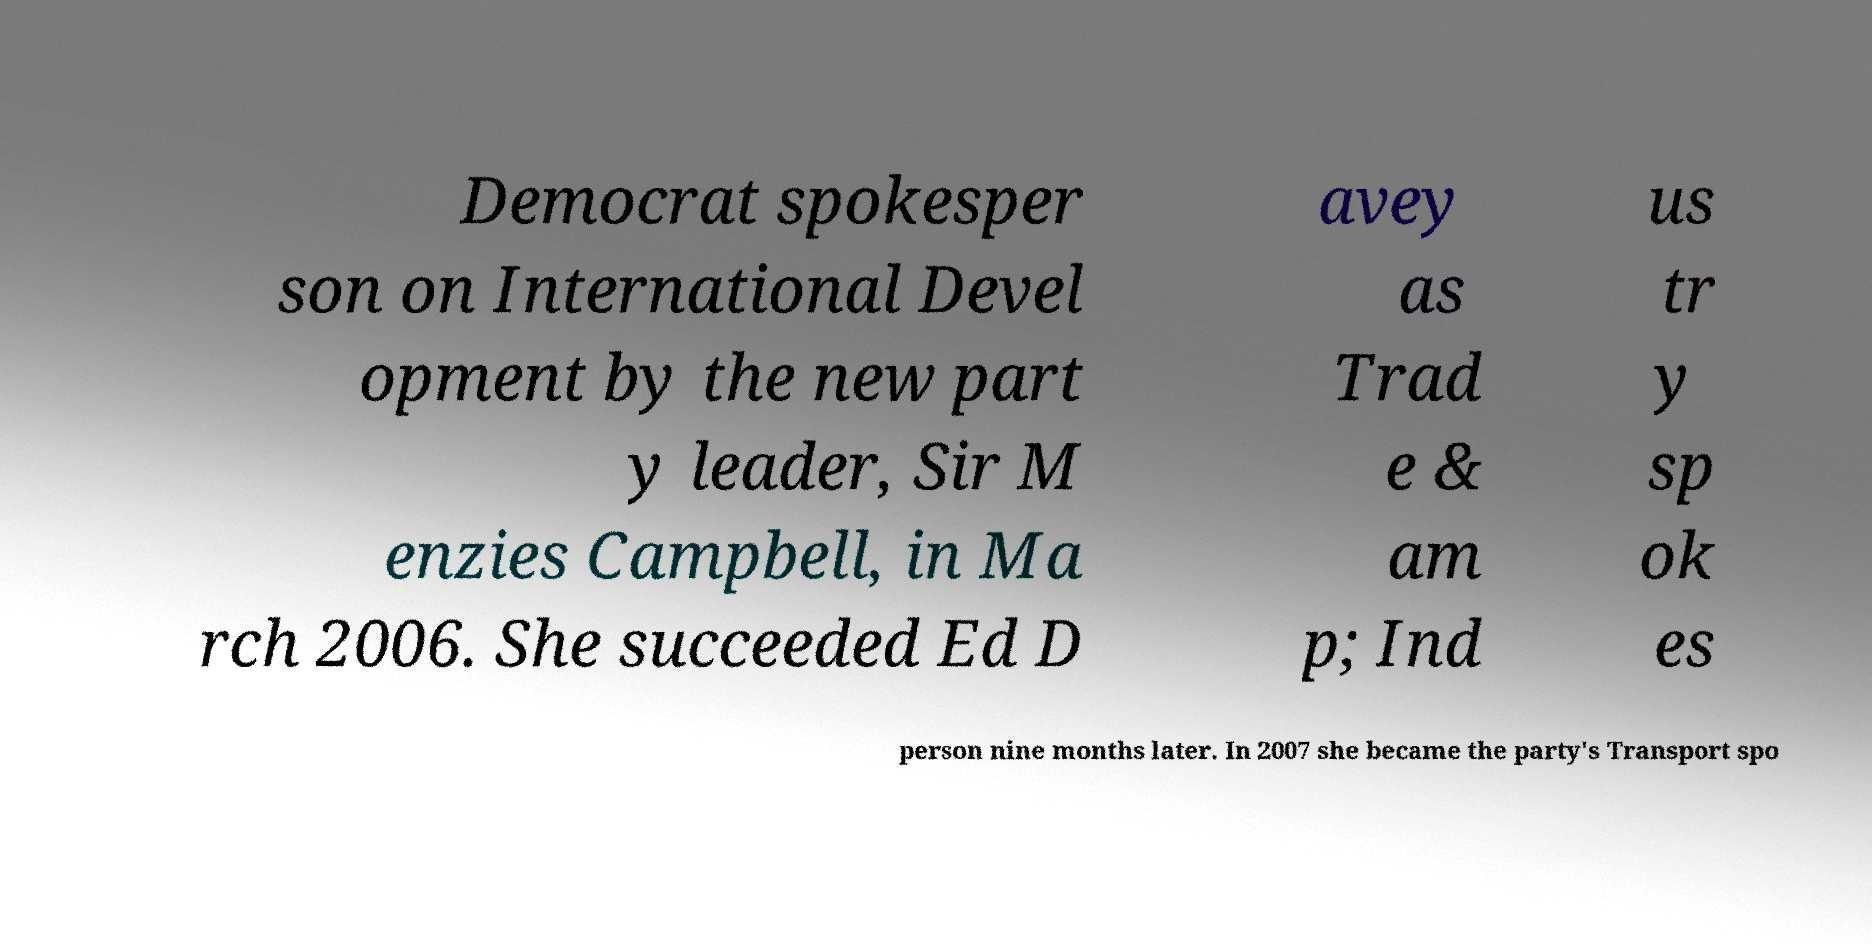Please read and relay the text visible in this image. What does it say? Democrat spokesper son on International Devel opment by the new part y leader, Sir M enzies Campbell, in Ma rch 2006. She succeeded Ed D avey as Trad e & am p; Ind us tr y sp ok es person nine months later. In 2007 she became the party's Transport spo 